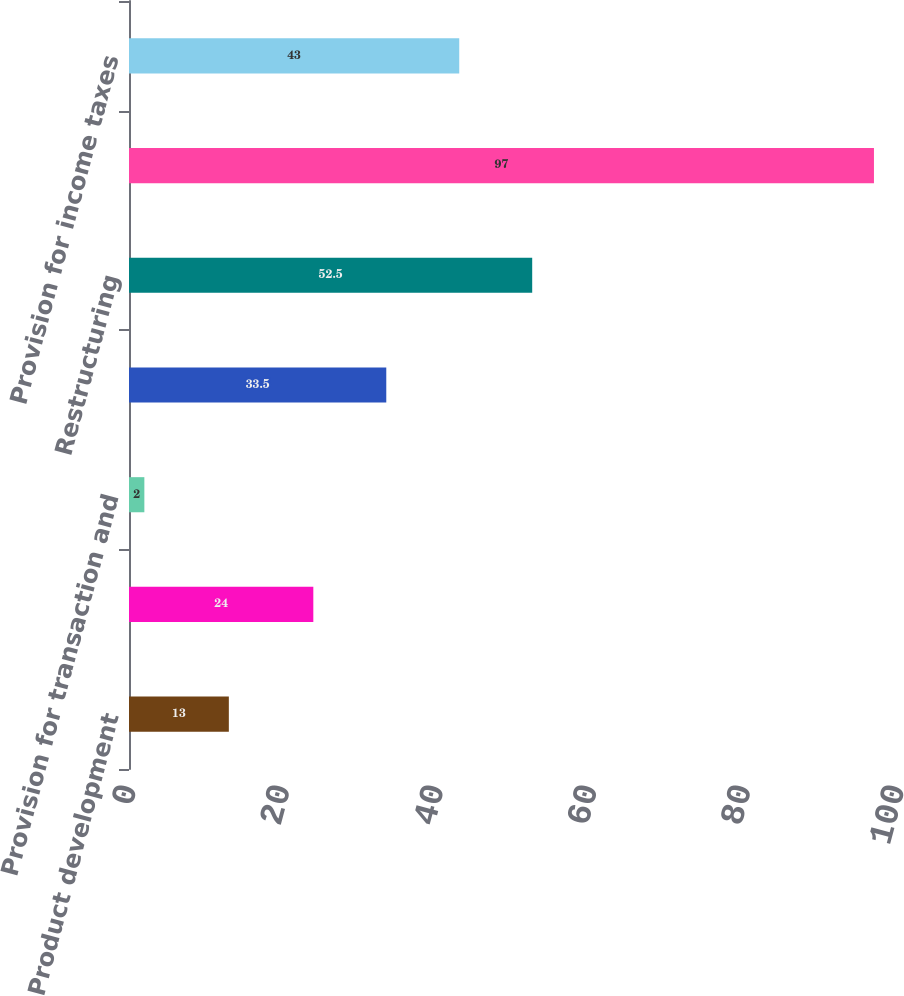<chart> <loc_0><loc_0><loc_500><loc_500><bar_chart><fcel>Product development<fcel>General and administrative<fcel>Provision for transaction and<fcel>Amortization of acquired<fcel>Restructuring<fcel>Interest and other income<fcel>Provision for income taxes<nl><fcel>13<fcel>24<fcel>2<fcel>33.5<fcel>52.5<fcel>97<fcel>43<nl></chart> 